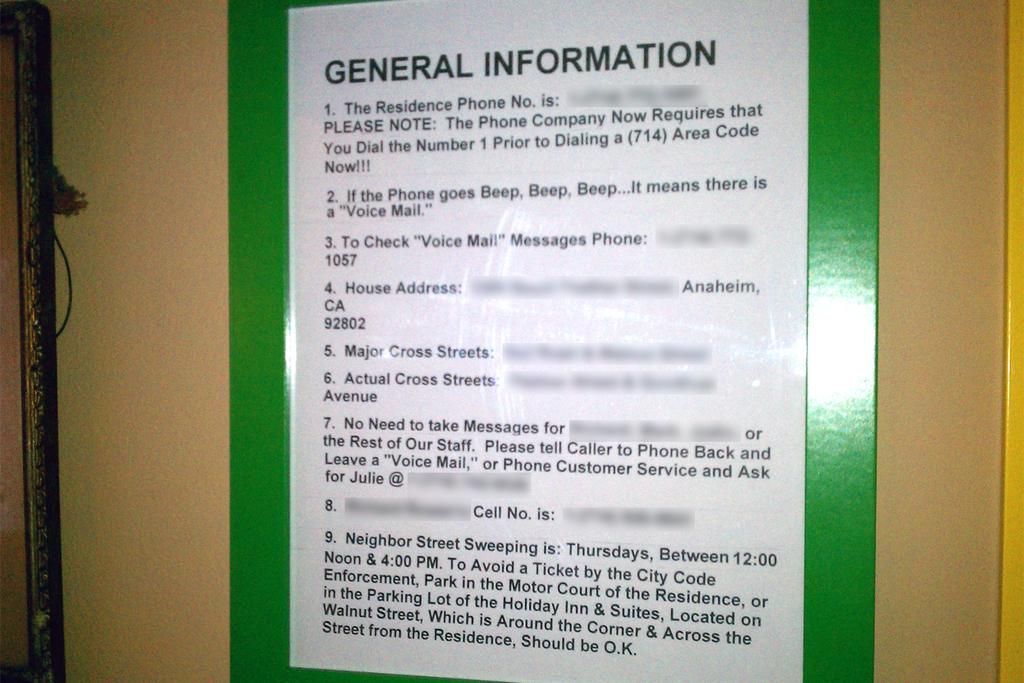What is in bold letters at the top of the poster?
Your answer should be very brief. General information. How many pieces of information is on this paper?
Your answer should be very brief. 9. 